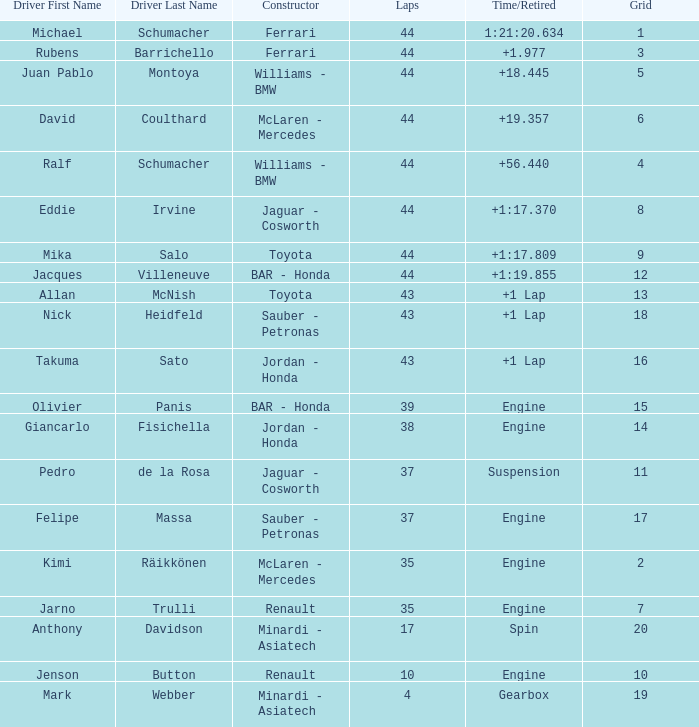What was the fewest laps for somone who finished +18.445? 44.0. 